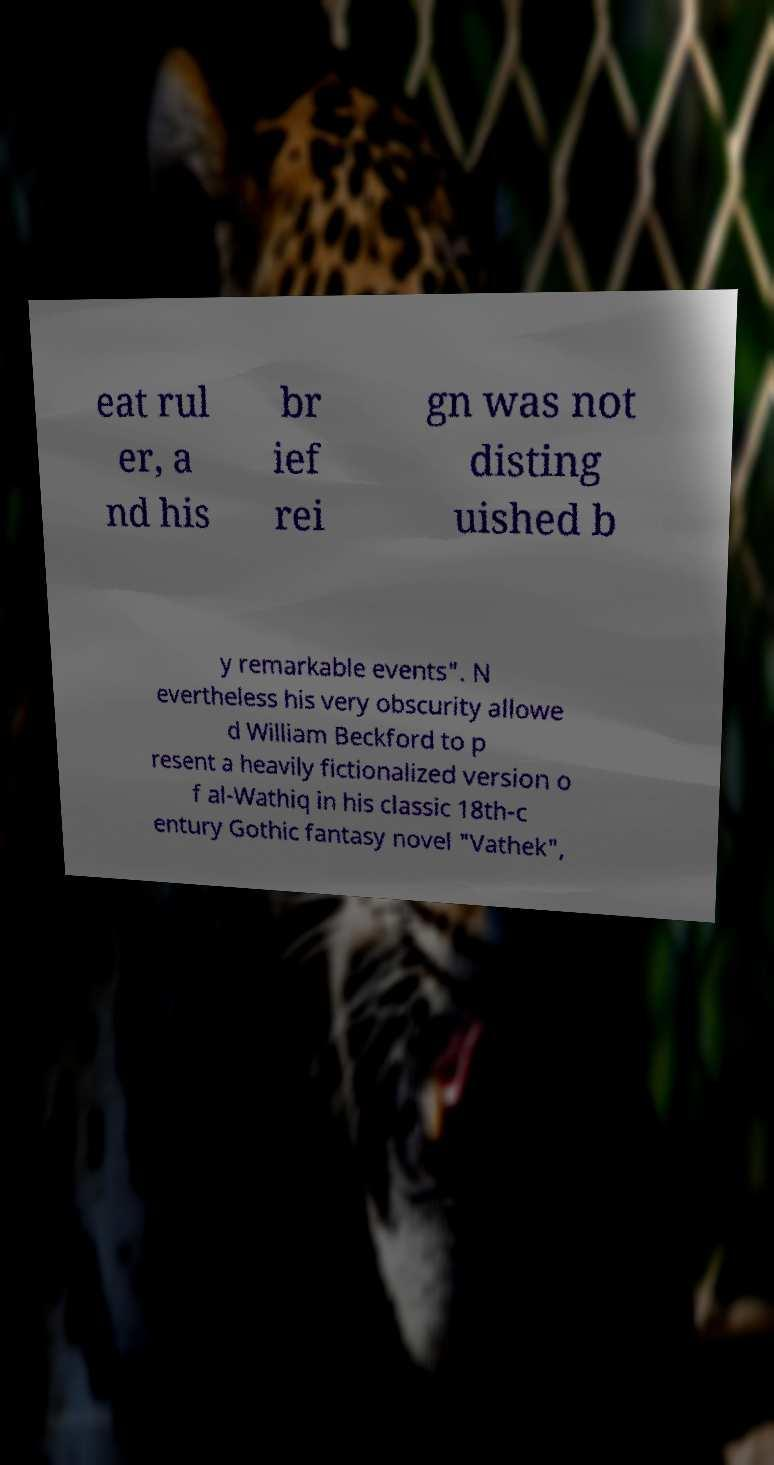What messages or text are displayed in this image? I need them in a readable, typed format. eat rul er, a nd his br ief rei gn was not disting uished b y remarkable events". N evertheless his very obscurity allowe d William Beckford to p resent a heavily fictionalized version o f al-Wathiq in his classic 18th-c entury Gothic fantasy novel "Vathek", 